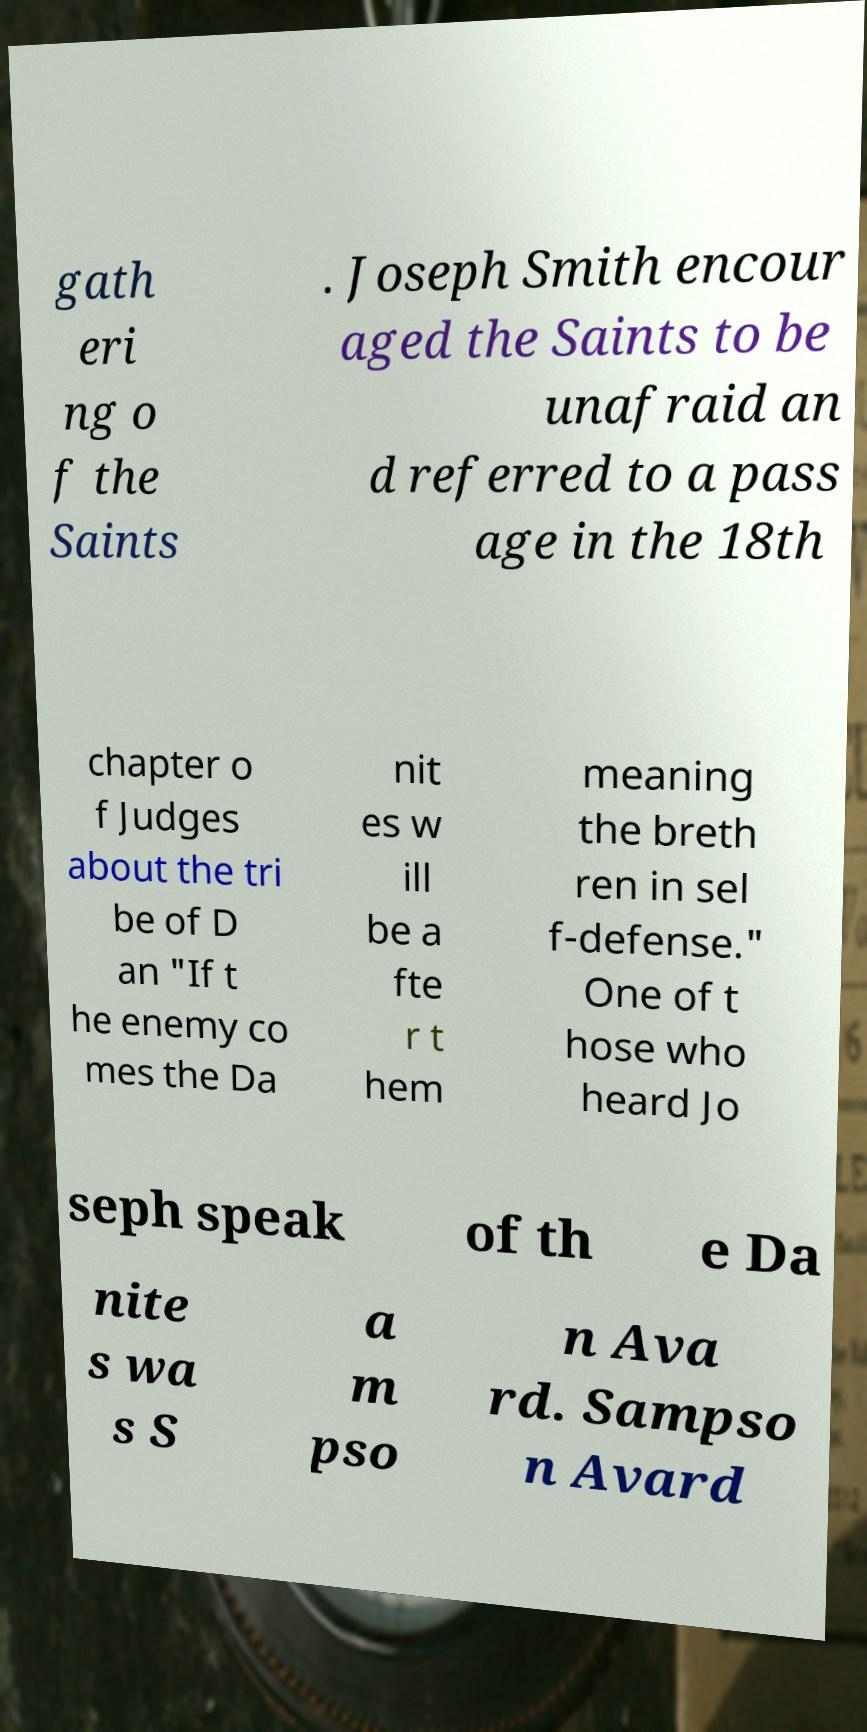For documentation purposes, I need the text within this image transcribed. Could you provide that? gath eri ng o f the Saints . Joseph Smith encour aged the Saints to be unafraid an d referred to a pass age in the 18th chapter o f Judges about the tri be of D an "If t he enemy co mes the Da nit es w ill be a fte r t hem meaning the breth ren in sel f-defense." One of t hose who heard Jo seph speak of th e Da nite s wa s S a m pso n Ava rd. Sampso n Avard 